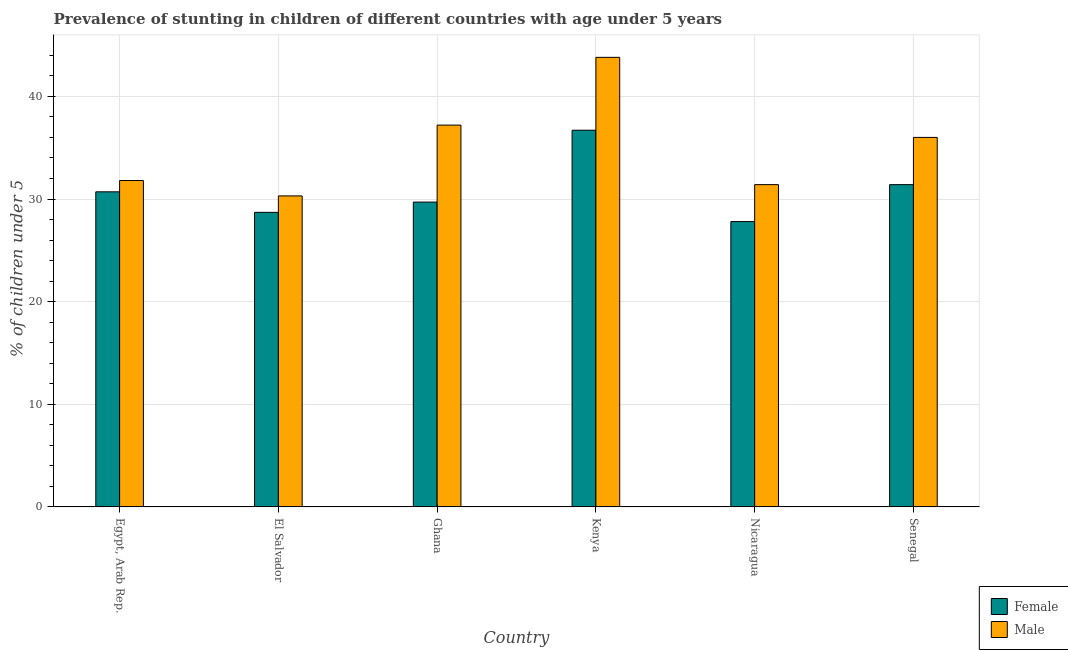How many different coloured bars are there?
Your answer should be very brief. 2. How many groups of bars are there?
Your answer should be compact. 6. How many bars are there on the 5th tick from the left?
Give a very brief answer. 2. How many bars are there on the 5th tick from the right?
Provide a short and direct response. 2. What is the label of the 3rd group of bars from the left?
Make the answer very short. Ghana. In how many cases, is the number of bars for a given country not equal to the number of legend labels?
Give a very brief answer. 0. What is the percentage of stunted male children in Kenya?
Provide a succinct answer. 43.8. Across all countries, what is the maximum percentage of stunted female children?
Give a very brief answer. 36.7. Across all countries, what is the minimum percentage of stunted female children?
Offer a very short reply. 27.8. In which country was the percentage of stunted female children maximum?
Ensure brevity in your answer.  Kenya. In which country was the percentage of stunted male children minimum?
Keep it short and to the point. El Salvador. What is the total percentage of stunted male children in the graph?
Ensure brevity in your answer.  210.5. What is the difference between the percentage of stunted male children in Egypt, Arab Rep. and that in Senegal?
Offer a very short reply. -4.2. What is the difference between the percentage of stunted male children in Ghana and the percentage of stunted female children in El Salvador?
Make the answer very short. 8.5. What is the average percentage of stunted male children per country?
Your answer should be very brief. 35.08. What is the difference between the percentage of stunted female children and percentage of stunted male children in El Salvador?
Provide a short and direct response. -1.6. What is the ratio of the percentage of stunted male children in Kenya to that in Nicaragua?
Your answer should be compact. 1.39. What is the difference between the highest and the second highest percentage of stunted female children?
Your answer should be compact. 5.3. What is the difference between the highest and the lowest percentage of stunted male children?
Give a very brief answer. 13.5. In how many countries, is the percentage of stunted male children greater than the average percentage of stunted male children taken over all countries?
Your answer should be compact. 3. Is the sum of the percentage of stunted male children in Kenya and Nicaragua greater than the maximum percentage of stunted female children across all countries?
Your answer should be compact. Yes. What does the 1st bar from the right in El Salvador represents?
Offer a very short reply. Male. Are all the bars in the graph horizontal?
Offer a terse response. No. What is the difference between two consecutive major ticks on the Y-axis?
Your response must be concise. 10. How many legend labels are there?
Keep it short and to the point. 2. What is the title of the graph?
Keep it short and to the point. Prevalence of stunting in children of different countries with age under 5 years. What is the label or title of the Y-axis?
Make the answer very short.  % of children under 5. What is the  % of children under 5 of Female in Egypt, Arab Rep.?
Give a very brief answer. 30.7. What is the  % of children under 5 in Male in Egypt, Arab Rep.?
Your answer should be compact. 31.8. What is the  % of children under 5 in Female in El Salvador?
Ensure brevity in your answer.  28.7. What is the  % of children under 5 of Male in El Salvador?
Provide a succinct answer. 30.3. What is the  % of children under 5 in Female in Ghana?
Give a very brief answer. 29.7. What is the  % of children under 5 of Male in Ghana?
Provide a succinct answer. 37.2. What is the  % of children under 5 in Female in Kenya?
Your answer should be very brief. 36.7. What is the  % of children under 5 in Male in Kenya?
Provide a succinct answer. 43.8. What is the  % of children under 5 in Female in Nicaragua?
Your answer should be compact. 27.8. What is the  % of children under 5 in Male in Nicaragua?
Provide a short and direct response. 31.4. What is the  % of children under 5 of Female in Senegal?
Your answer should be very brief. 31.4. What is the  % of children under 5 in Male in Senegal?
Offer a very short reply. 36. Across all countries, what is the maximum  % of children under 5 in Female?
Offer a terse response. 36.7. Across all countries, what is the maximum  % of children under 5 in Male?
Provide a short and direct response. 43.8. Across all countries, what is the minimum  % of children under 5 in Female?
Give a very brief answer. 27.8. Across all countries, what is the minimum  % of children under 5 of Male?
Your answer should be very brief. 30.3. What is the total  % of children under 5 of Female in the graph?
Offer a terse response. 185. What is the total  % of children under 5 in Male in the graph?
Offer a terse response. 210.5. What is the difference between the  % of children under 5 of Male in Egypt, Arab Rep. and that in El Salvador?
Offer a very short reply. 1.5. What is the difference between the  % of children under 5 in Female in Egypt, Arab Rep. and that in Ghana?
Provide a short and direct response. 1. What is the difference between the  % of children under 5 in Male in Egypt, Arab Rep. and that in Ghana?
Make the answer very short. -5.4. What is the difference between the  % of children under 5 in Male in Egypt, Arab Rep. and that in Kenya?
Give a very brief answer. -12. What is the difference between the  % of children under 5 in Female in Egypt, Arab Rep. and that in Nicaragua?
Offer a very short reply. 2.9. What is the difference between the  % of children under 5 in Male in Egypt, Arab Rep. and that in Nicaragua?
Your answer should be compact. 0.4. What is the difference between the  % of children under 5 in Male in El Salvador and that in Kenya?
Your answer should be compact. -13.5. What is the difference between the  % of children under 5 in Female in El Salvador and that in Senegal?
Provide a succinct answer. -2.7. What is the difference between the  % of children under 5 in Male in Ghana and that in Nicaragua?
Give a very brief answer. 5.8. What is the difference between the  % of children under 5 in Female in Ghana and that in Senegal?
Provide a short and direct response. -1.7. What is the difference between the  % of children under 5 in Male in Kenya and that in Nicaragua?
Your answer should be very brief. 12.4. What is the difference between the  % of children under 5 of Female in Kenya and that in Senegal?
Offer a very short reply. 5.3. What is the difference between the  % of children under 5 of Male in Kenya and that in Senegal?
Provide a short and direct response. 7.8. What is the difference between the  % of children under 5 in Female in Egypt, Arab Rep. and the  % of children under 5 in Male in Nicaragua?
Provide a short and direct response. -0.7. What is the difference between the  % of children under 5 in Female in Egypt, Arab Rep. and the  % of children under 5 in Male in Senegal?
Ensure brevity in your answer.  -5.3. What is the difference between the  % of children under 5 of Female in El Salvador and the  % of children under 5 of Male in Ghana?
Provide a short and direct response. -8.5. What is the difference between the  % of children under 5 of Female in El Salvador and the  % of children under 5 of Male in Kenya?
Provide a short and direct response. -15.1. What is the difference between the  % of children under 5 of Female in Ghana and the  % of children under 5 of Male in Kenya?
Offer a terse response. -14.1. What is the difference between the  % of children under 5 of Female in Ghana and the  % of children under 5 of Male in Nicaragua?
Ensure brevity in your answer.  -1.7. What is the difference between the  % of children under 5 in Female in Ghana and the  % of children under 5 in Male in Senegal?
Your response must be concise. -6.3. What is the average  % of children under 5 in Female per country?
Keep it short and to the point. 30.83. What is the average  % of children under 5 of Male per country?
Your answer should be very brief. 35.08. What is the difference between the  % of children under 5 in Female and  % of children under 5 in Male in Egypt, Arab Rep.?
Make the answer very short. -1.1. What is the difference between the  % of children under 5 of Female and  % of children under 5 of Male in El Salvador?
Offer a terse response. -1.6. What is the difference between the  % of children under 5 in Female and  % of children under 5 in Male in Ghana?
Provide a short and direct response. -7.5. What is the difference between the  % of children under 5 of Female and  % of children under 5 of Male in Kenya?
Your answer should be very brief. -7.1. What is the difference between the  % of children under 5 of Female and  % of children under 5 of Male in Nicaragua?
Provide a short and direct response. -3.6. What is the difference between the  % of children under 5 of Female and  % of children under 5 of Male in Senegal?
Your response must be concise. -4.6. What is the ratio of the  % of children under 5 of Female in Egypt, Arab Rep. to that in El Salvador?
Offer a very short reply. 1.07. What is the ratio of the  % of children under 5 of Male in Egypt, Arab Rep. to that in El Salvador?
Your answer should be compact. 1.05. What is the ratio of the  % of children under 5 in Female in Egypt, Arab Rep. to that in Ghana?
Give a very brief answer. 1.03. What is the ratio of the  % of children under 5 in Male in Egypt, Arab Rep. to that in Ghana?
Offer a very short reply. 0.85. What is the ratio of the  % of children under 5 in Female in Egypt, Arab Rep. to that in Kenya?
Make the answer very short. 0.84. What is the ratio of the  % of children under 5 of Male in Egypt, Arab Rep. to that in Kenya?
Make the answer very short. 0.73. What is the ratio of the  % of children under 5 in Female in Egypt, Arab Rep. to that in Nicaragua?
Your response must be concise. 1.1. What is the ratio of the  % of children under 5 of Male in Egypt, Arab Rep. to that in Nicaragua?
Offer a terse response. 1.01. What is the ratio of the  % of children under 5 in Female in Egypt, Arab Rep. to that in Senegal?
Give a very brief answer. 0.98. What is the ratio of the  % of children under 5 of Male in Egypt, Arab Rep. to that in Senegal?
Ensure brevity in your answer.  0.88. What is the ratio of the  % of children under 5 of Female in El Salvador to that in Ghana?
Offer a very short reply. 0.97. What is the ratio of the  % of children under 5 in Male in El Salvador to that in Ghana?
Ensure brevity in your answer.  0.81. What is the ratio of the  % of children under 5 in Female in El Salvador to that in Kenya?
Your answer should be compact. 0.78. What is the ratio of the  % of children under 5 of Male in El Salvador to that in Kenya?
Provide a short and direct response. 0.69. What is the ratio of the  % of children under 5 of Female in El Salvador to that in Nicaragua?
Make the answer very short. 1.03. What is the ratio of the  % of children under 5 of Female in El Salvador to that in Senegal?
Offer a terse response. 0.91. What is the ratio of the  % of children under 5 of Male in El Salvador to that in Senegal?
Ensure brevity in your answer.  0.84. What is the ratio of the  % of children under 5 of Female in Ghana to that in Kenya?
Give a very brief answer. 0.81. What is the ratio of the  % of children under 5 in Male in Ghana to that in Kenya?
Offer a terse response. 0.85. What is the ratio of the  % of children under 5 of Female in Ghana to that in Nicaragua?
Provide a succinct answer. 1.07. What is the ratio of the  % of children under 5 in Male in Ghana to that in Nicaragua?
Make the answer very short. 1.18. What is the ratio of the  % of children under 5 of Female in Ghana to that in Senegal?
Your answer should be compact. 0.95. What is the ratio of the  % of children under 5 in Female in Kenya to that in Nicaragua?
Offer a terse response. 1.32. What is the ratio of the  % of children under 5 in Male in Kenya to that in Nicaragua?
Offer a very short reply. 1.39. What is the ratio of the  % of children under 5 in Female in Kenya to that in Senegal?
Your answer should be compact. 1.17. What is the ratio of the  % of children under 5 in Male in Kenya to that in Senegal?
Make the answer very short. 1.22. What is the ratio of the  % of children under 5 of Female in Nicaragua to that in Senegal?
Your answer should be very brief. 0.89. What is the ratio of the  % of children under 5 of Male in Nicaragua to that in Senegal?
Your answer should be very brief. 0.87. What is the difference between the highest and the lowest  % of children under 5 in Female?
Your response must be concise. 8.9. What is the difference between the highest and the lowest  % of children under 5 in Male?
Make the answer very short. 13.5. 